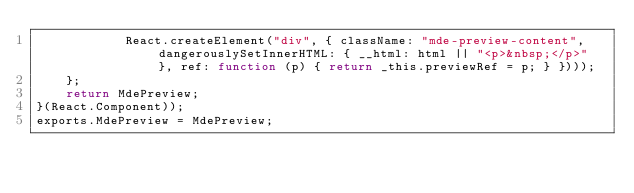<code> <loc_0><loc_0><loc_500><loc_500><_JavaScript_>            React.createElement("div", { className: "mde-preview-content", dangerouslySetInnerHTML: { __html: html || "<p>&nbsp;</p>" }, ref: function (p) { return _this.previewRef = p; } })));
    };
    return MdePreview;
}(React.Component));
exports.MdePreview = MdePreview;
</code> 